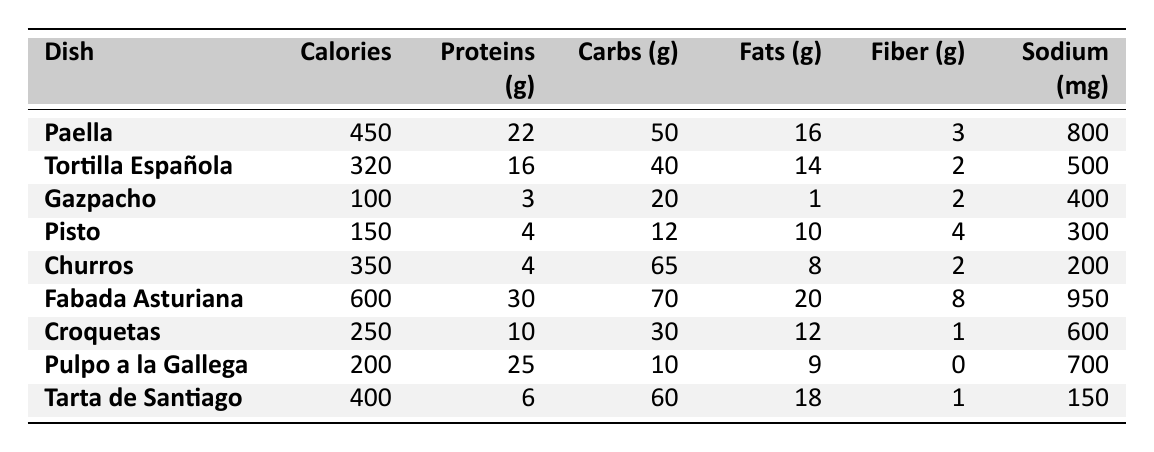What is the calorie content of Fabada Asturiana? The table lists the calorie content under the Fabada Asturiana row, which shows 600 calories.
Answer: 600 How many grams of protein does Pulpo a la Gallega contain? By looking at the row for Pulpo a la Gallega, the table indicates it has 25 grams of protein.
Answer: 25 Which dish has the highest amount of fats? The table shows that Fabada Asturiana has the highest fat content at 20 grams.
Answer: Fabada Asturiana What is the total calorie count for Paella and Tarta de Santiago combined? The calories for Paella (450) and Tarta de Santiago (400) are summed: 450 + 400 = 850.
Answer: 850 Is Gazpacho low in calories compared to other dishes? Gazpacho has 100 calories, which is lower than all other dishes listed in the table, confirming it is low in calories.
Answer: Yes What is the average amount of fiber across all the dishes? To calculate the average fiber: (3 + 2 + 2 + 4 + 2 + 8 + 1 + 0 + 1) = 23, then divide by 9 dishes: 23 / 9 ≈ 2.56.
Answer: About 2.56 Which dish has the least amount of carbohydrates? By reviewing the carbohydrates column, Pisto has the least at 12 grams.
Answer: Pisto Are there any dishes with more than 30 grams of proteins? Checking the proteins column reveals that Fabada Asturiana (30 grams) and Pulpo a la Gallega (25 grams) but only Fabada reaches beyond 30 grams, thus confirming the statement is true.
Answer: Yes What are the sodium levels of Tortilla Española and Churros combined? The sodium for Tortilla Española (500 mg) and Churros (200 mg) is added: 500 + 200 = 700 mg.
Answer: 700 mg Which dish has the highest fiber content, and how much is it? Analyzing the fiber column, Fabada Asturiana has the highest fiber amount of 8 grams.
Answer: Fabada Asturiana, 8 grams 